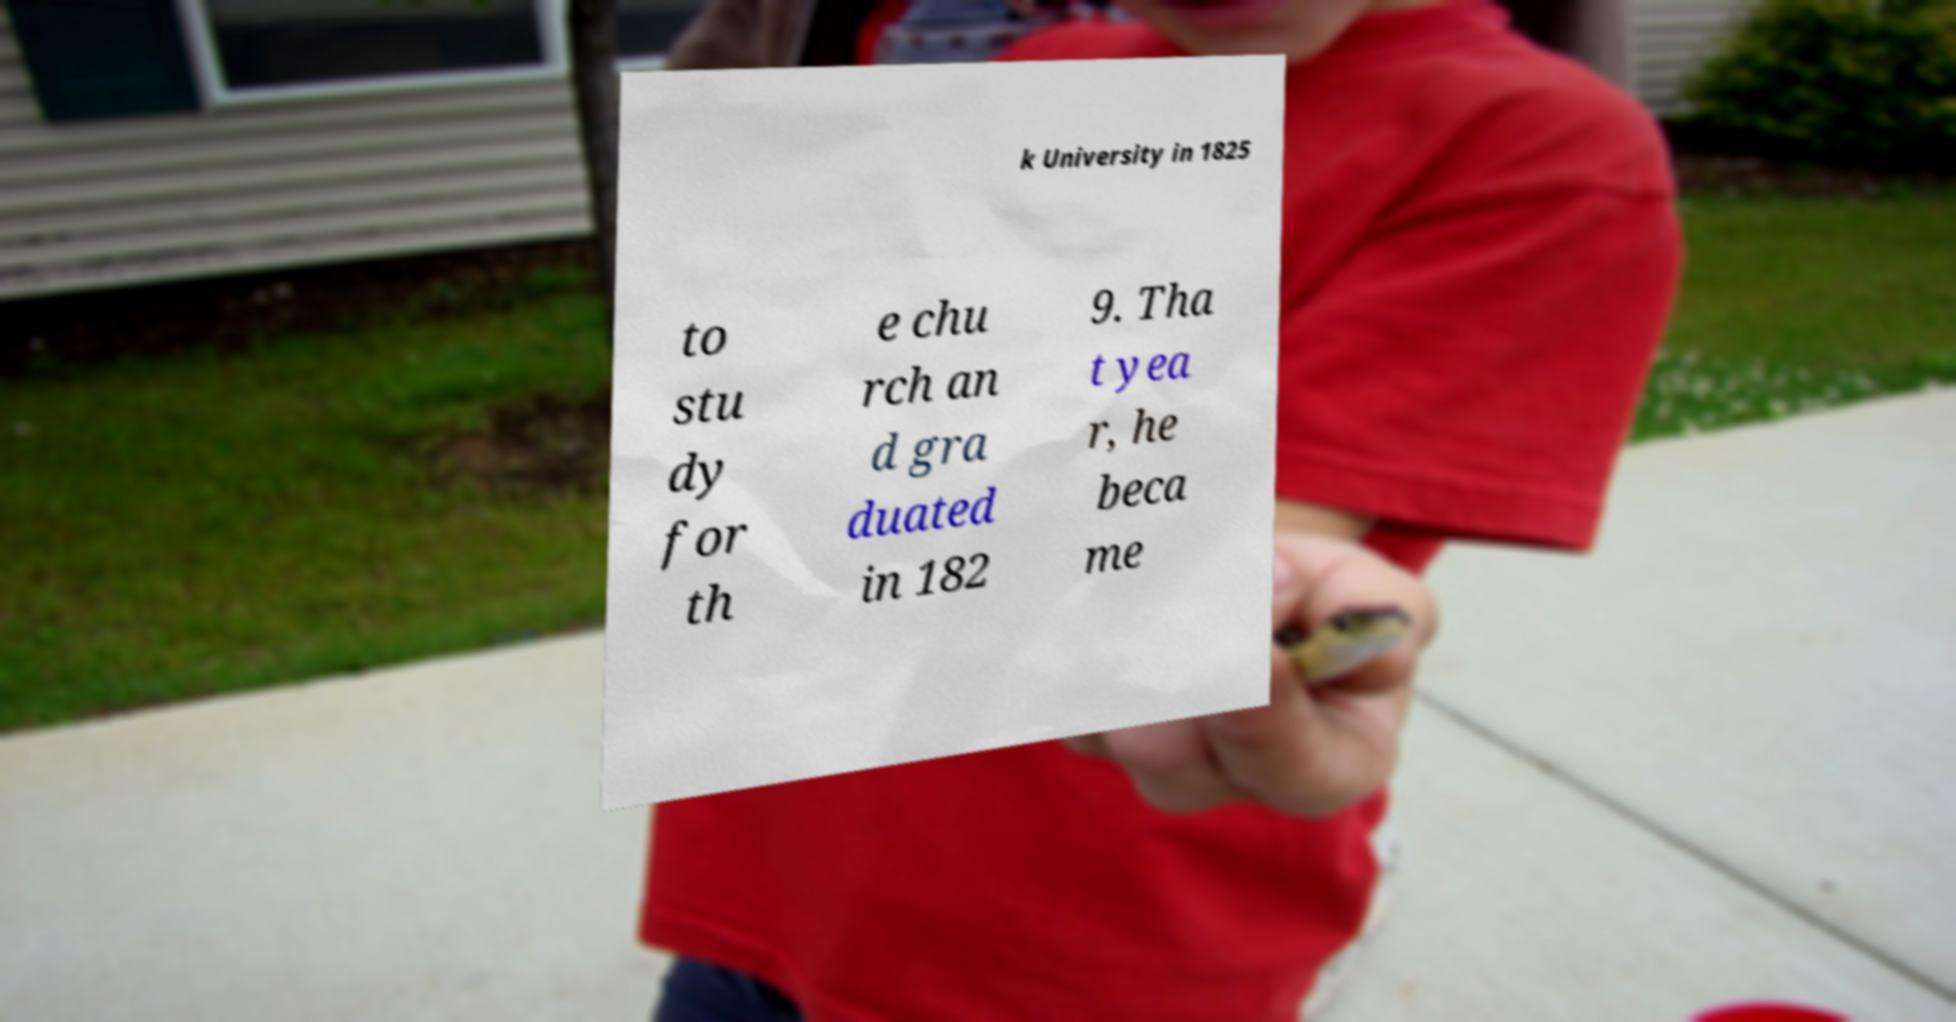What messages or text are displayed in this image? I need them in a readable, typed format. k University in 1825 to stu dy for th e chu rch an d gra duated in 182 9. Tha t yea r, he beca me 